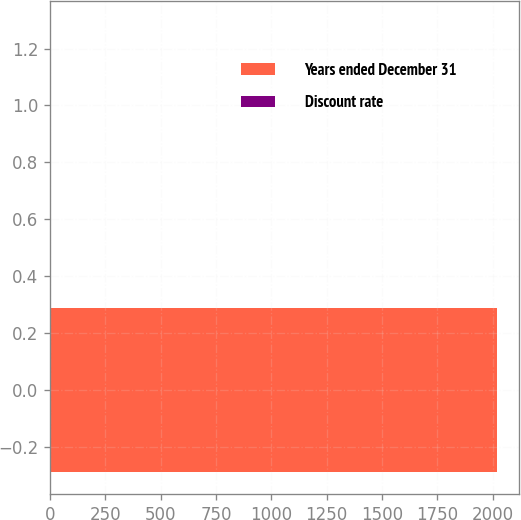Convert chart to OTSL. <chart><loc_0><loc_0><loc_500><loc_500><bar_chart><fcel>Years ended December 31<fcel>Discount rate<nl><fcel>2017<fcel>4.05<nl></chart> 